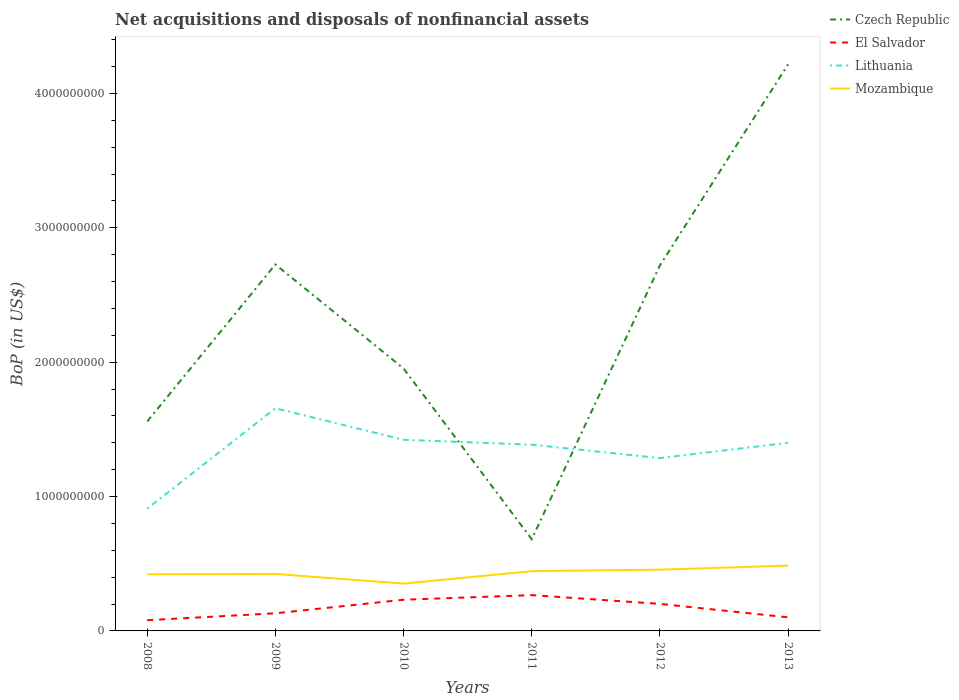Does the line corresponding to Lithuania intersect with the line corresponding to Mozambique?
Your response must be concise. No. Is the number of lines equal to the number of legend labels?
Ensure brevity in your answer.  Yes. Across all years, what is the maximum Balance of Payments in Mozambique?
Provide a short and direct response. 3.52e+08. In which year was the Balance of Payments in Mozambique maximum?
Your response must be concise. 2010. What is the total Balance of Payments in Mozambique in the graph?
Offer a terse response. 6.94e+07. What is the difference between the highest and the second highest Balance of Payments in Mozambique?
Provide a short and direct response. 1.34e+08. How many lines are there?
Offer a terse response. 4. How many years are there in the graph?
Offer a very short reply. 6. Are the values on the major ticks of Y-axis written in scientific E-notation?
Your answer should be compact. No. How many legend labels are there?
Your answer should be compact. 4. How are the legend labels stacked?
Ensure brevity in your answer.  Vertical. What is the title of the graph?
Ensure brevity in your answer.  Net acquisitions and disposals of nonfinancial assets. What is the label or title of the X-axis?
Provide a succinct answer. Years. What is the label or title of the Y-axis?
Offer a terse response. BoP (in US$). What is the BoP (in US$) in Czech Republic in 2008?
Offer a very short reply. 1.56e+09. What is the BoP (in US$) in El Salvador in 2008?
Your response must be concise. 7.98e+07. What is the BoP (in US$) in Lithuania in 2008?
Your response must be concise. 9.10e+08. What is the BoP (in US$) of Mozambique in 2008?
Offer a very short reply. 4.21e+08. What is the BoP (in US$) of Czech Republic in 2009?
Your answer should be compact. 2.73e+09. What is the BoP (in US$) of El Salvador in 2009?
Keep it short and to the point. 1.31e+08. What is the BoP (in US$) in Lithuania in 2009?
Keep it short and to the point. 1.66e+09. What is the BoP (in US$) of Mozambique in 2009?
Your response must be concise. 4.24e+08. What is the BoP (in US$) in Czech Republic in 2010?
Ensure brevity in your answer.  1.95e+09. What is the BoP (in US$) of El Salvador in 2010?
Make the answer very short. 2.32e+08. What is the BoP (in US$) in Lithuania in 2010?
Your answer should be compact. 1.42e+09. What is the BoP (in US$) of Mozambique in 2010?
Ensure brevity in your answer.  3.52e+08. What is the BoP (in US$) of Czech Republic in 2011?
Give a very brief answer. 6.83e+08. What is the BoP (in US$) of El Salvador in 2011?
Provide a succinct answer. 2.66e+08. What is the BoP (in US$) in Lithuania in 2011?
Your response must be concise. 1.39e+09. What is the BoP (in US$) of Mozambique in 2011?
Offer a terse response. 4.45e+08. What is the BoP (in US$) in Czech Republic in 2012?
Provide a short and direct response. 2.72e+09. What is the BoP (in US$) of El Salvador in 2012?
Offer a terse response. 2.01e+08. What is the BoP (in US$) of Lithuania in 2012?
Your answer should be compact. 1.29e+09. What is the BoP (in US$) in Mozambique in 2012?
Give a very brief answer. 4.56e+08. What is the BoP (in US$) in Czech Republic in 2013?
Your answer should be compact. 4.22e+09. What is the BoP (in US$) of El Salvador in 2013?
Your response must be concise. 1.01e+08. What is the BoP (in US$) of Lithuania in 2013?
Ensure brevity in your answer.  1.40e+09. What is the BoP (in US$) of Mozambique in 2013?
Keep it short and to the point. 4.86e+08. Across all years, what is the maximum BoP (in US$) of Czech Republic?
Keep it short and to the point. 4.22e+09. Across all years, what is the maximum BoP (in US$) in El Salvador?
Offer a very short reply. 2.66e+08. Across all years, what is the maximum BoP (in US$) in Lithuania?
Provide a succinct answer. 1.66e+09. Across all years, what is the maximum BoP (in US$) in Mozambique?
Your answer should be compact. 4.86e+08. Across all years, what is the minimum BoP (in US$) of Czech Republic?
Give a very brief answer. 6.83e+08. Across all years, what is the minimum BoP (in US$) of El Salvador?
Your response must be concise. 7.98e+07. Across all years, what is the minimum BoP (in US$) in Lithuania?
Offer a very short reply. 9.10e+08. Across all years, what is the minimum BoP (in US$) in Mozambique?
Give a very brief answer. 3.52e+08. What is the total BoP (in US$) of Czech Republic in the graph?
Give a very brief answer. 1.39e+1. What is the total BoP (in US$) in El Salvador in the graph?
Offer a terse response. 1.01e+09. What is the total BoP (in US$) in Lithuania in the graph?
Provide a short and direct response. 8.06e+09. What is the total BoP (in US$) of Mozambique in the graph?
Your answer should be compact. 2.58e+09. What is the difference between the BoP (in US$) in Czech Republic in 2008 and that in 2009?
Give a very brief answer. -1.17e+09. What is the difference between the BoP (in US$) of El Salvador in 2008 and that in 2009?
Your answer should be compact. -5.14e+07. What is the difference between the BoP (in US$) of Lithuania in 2008 and that in 2009?
Offer a very short reply. -7.47e+08. What is the difference between the BoP (in US$) in Mozambique in 2008 and that in 2009?
Provide a succinct answer. -2.73e+06. What is the difference between the BoP (in US$) in Czech Republic in 2008 and that in 2010?
Provide a succinct answer. -3.94e+08. What is the difference between the BoP (in US$) of El Salvador in 2008 and that in 2010?
Provide a succinct answer. -1.52e+08. What is the difference between the BoP (in US$) of Lithuania in 2008 and that in 2010?
Provide a short and direct response. -5.12e+08. What is the difference between the BoP (in US$) in Mozambique in 2008 and that in 2010?
Give a very brief answer. 6.94e+07. What is the difference between the BoP (in US$) of Czech Republic in 2008 and that in 2011?
Provide a short and direct response. 8.76e+08. What is the difference between the BoP (in US$) of El Salvador in 2008 and that in 2011?
Offer a terse response. -1.87e+08. What is the difference between the BoP (in US$) of Lithuania in 2008 and that in 2011?
Give a very brief answer. -4.76e+08. What is the difference between the BoP (in US$) of Mozambique in 2008 and that in 2011?
Your response must be concise. -2.33e+07. What is the difference between the BoP (in US$) of Czech Republic in 2008 and that in 2012?
Ensure brevity in your answer.  -1.16e+09. What is the difference between the BoP (in US$) in El Salvador in 2008 and that in 2012?
Make the answer very short. -1.21e+08. What is the difference between the BoP (in US$) of Lithuania in 2008 and that in 2012?
Give a very brief answer. -3.76e+08. What is the difference between the BoP (in US$) of Mozambique in 2008 and that in 2012?
Offer a terse response. -3.45e+07. What is the difference between the BoP (in US$) in Czech Republic in 2008 and that in 2013?
Keep it short and to the point. -2.66e+09. What is the difference between the BoP (in US$) of El Salvador in 2008 and that in 2013?
Make the answer very short. -2.13e+07. What is the difference between the BoP (in US$) of Lithuania in 2008 and that in 2013?
Keep it short and to the point. -4.90e+08. What is the difference between the BoP (in US$) in Mozambique in 2008 and that in 2013?
Your response must be concise. -6.43e+07. What is the difference between the BoP (in US$) of Czech Republic in 2009 and that in 2010?
Make the answer very short. 7.74e+08. What is the difference between the BoP (in US$) in El Salvador in 2009 and that in 2010?
Make the answer very short. -1.01e+08. What is the difference between the BoP (in US$) of Lithuania in 2009 and that in 2010?
Your answer should be compact. 2.35e+08. What is the difference between the BoP (in US$) in Mozambique in 2009 and that in 2010?
Offer a terse response. 7.21e+07. What is the difference between the BoP (in US$) of Czech Republic in 2009 and that in 2011?
Provide a succinct answer. 2.04e+09. What is the difference between the BoP (in US$) of El Salvador in 2009 and that in 2011?
Offer a very short reply. -1.35e+08. What is the difference between the BoP (in US$) of Lithuania in 2009 and that in 2011?
Offer a very short reply. 2.71e+08. What is the difference between the BoP (in US$) in Mozambique in 2009 and that in 2011?
Make the answer very short. -2.06e+07. What is the difference between the BoP (in US$) of Czech Republic in 2009 and that in 2012?
Provide a short and direct response. 7.45e+06. What is the difference between the BoP (in US$) in El Salvador in 2009 and that in 2012?
Offer a very short reply. -7.00e+07. What is the difference between the BoP (in US$) of Lithuania in 2009 and that in 2012?
Offer a terse response. 3.71e+08. What is the difference between the BoP (in US$) in Mozambique in 2009 and that in 2012?
Offer a very short reply. -3.18e+07. What is the difference between the BoP (in US$) in Czech Republic in 2009 and that in 2013?
Your answer should be compact. -1.49e+09. What is the difference between the BoP (in US$) in El Salvador in 2009 and that in 2013?
Offer a terse response. 3.01e+07. What is the difference between the BoP (in US$) of Lithuania in 2009 and that in 2013?
Ensure brevity in your answer.  2.57e+08. What is the difference between the BoP (in US$) in Mozambique in 2009 and that in 2013?
Provide a short and direct response. -6.15e+07. What is the difference between the BoP (in US$) of Czech Republic in 2010 and that in 2011?
Offer a very short reply. 1.27e+09. What is the difference between the BoP (in US$) of El Salvador in 2010 and that in 2011?
Provide a short and direct response. -3.44e+07. What is the difference between the BoP (in US$) in Lithuania in 2010 and that in 2011?
Keep it short and to the point. 3.64e+07. What is the difference between the BoP (in US$) of Mozambique in 2010 and that in 2011?
Your answer should be compact. -9.28e+07. What is the difference between the BoP (in US$) in Czech Republic in 2010 and that in 2012?
Ensure brevity in your answer.  -7.66e+08. What is the difference between the BoP (in US$) of El Salvador in 2010 and that in 2012?
Ensure brevity in your answer.  3.08e+07. What is the difference between the BoP (in US$) of Lithuania in 2010 and that in 2012?
Ensure brevity in your answer.  1.36e+08. What is the difference between the BoP (in US$) in Mozambique in 2010 and that in 2012?
Your answer should be compact. -1.04e+08. What is the difference between the BoP (in US$) of Czech Republic in 2010 and that in 2013?
Offer a terse response. -2.26e+09. What is the difference between the BoP (in US$) of El Salvador in 2010 and that in 2013?
Provide a short and direct response. 1.31e+08. What is the difference between the BoP (in US$) of Lithuania in 2010 and that in 2013?
Make the answer very short. 2.24e+07. What is the difference between the BoP (in US$) in Mozambique in 2010 and that in 2013?
Provide a short and direct response. -1.34e+08. What is the difference between the BoP (in US$) in Czech Republic in 2011 and that in 2012?
Make the answer very short. -2.04e+09. What is the difference between the BoP (in US$) in El Salvador in 2011 and that in 2012?
Keep it short and to the point. 6.52e+07. What is the difference between the BoP (in US$) in Lithuania in 2011 and that in 2012?
Provide a short and direct response. 9.96e+07. What is the difference between the BoP (in US$) of Mozambique in 2011 and that in 2012?
Offer a very short reply. -1.11e+07. What is the difference between the BoP (in US$) in Czech Republic in 2011 and that in 2013?
Give a very brief answer. -3.53e+09. What is the difference between the BoP (in US$) of El Salvador in 2011 and that in 2013?
Your answer should be compact. 1.65e+08. What is the difference between the BoP (in US$) of Lithuania in 2011 and that in 2013?
Provide a short and direct response. -1.40e+07. What is the difference between the BoP (in US$) in Mozambique in 2011 and that in 2013?
Ensure brevity in your answer.  -4.09e+07. What is the difference between the BoP (in US$) of Czech Republic in 2012 and that in 2013?
Provide a succinct answer. -1.50e+09. What is the difference between the BoP (in US$) in El Salvador in 2012 and that in 2013?
Your answer should be very brief. 1.00e+08. What is the difference between the BoP (in US$) of Lithuania in 2012 and that in 2013?
Your answer should be very brief. -1.14e+08. What is the difference between the BoP (in US$) in Mozambique in 2012 and that in 2013?
Keep it short and to the point. -2.98e+07. What is the difference between the BoP (in US$) in Czech Republic in 2008 and the BoP (in US$) in El Salvador in 2009?
Ensure brevity in your answer.  1.43e+09. What is the difference between the BoP (in US$) of Czech Republic in 2008 and the BoP (in US$) of Lithuania in 2009?
Your response must be concise. -9.84e+07. What is the difference between the BoP (in US$) in Czech Republic in 2008 and the BoP (in US$) in Mozambique in 2009?
Your response must be concise. 1.13e+09. What is the difference between the BoP (in US$) in El Salvador in 2008 and the BoP (in US$) in Lithuania in 2009?
Offer a terse response. -1.58e+09. What is the difference between the BoP (in US$) in El Salvador in 2008 and the BoP (in US$) in Mozambique in 2009?
Ensure brevity in your answer.  -3.44e+08. What is the difference between the BoP (in US$) of Lithuania in 2008 and the BoP (in US$) of Mozambique in 2009?
Provide a short and direct response. 4.86e+08. What is the difference between the BoP (in US$) in Czech Republic in 2008 and the BoP (in US$) in El Salvador in 2010?
Make the answer very short. 1.33e+09. What is the difference between the BoP (in US$) of Czech Republic in 2008 and the BoP (in US$) of Lithuania in 2010?
Keep it short and to the point. 1.36e+08. What is the difference between the BoP (in US$) of Czech Republic in 2008 and the BoP (in US$) of Mozambique in 2010?
Provide a short and direct response. 1.21e+09. What is the difference between the BoP (in US$) of El Salvador in 2008 and the BoP (in US$) of Lithuania in 2010?
Offer a very short reply. -1.34e+09. What is the difference between the BoP (in US$) in El Salvador in 2008 and the BoP (in US$) in Mozambique in 2010?
Your answer should be compact. -2.72e+08. What is the difference between the BoP (in US$) of Lithuania in 2008 and the BoP (in US$) of Mozambique in 2010?
Your answer should be compact. 5.58e+08. What is the difference between the BoP (in US$) in Czech Republic in 2008 and the BoP (in US$) in El Salvador in 2011?
Ensure brevity in your answer.  1.29e+09. What is the difference between the BoP (in US$) in Czech Republic in 2008 and the BoP (in US$) in Lithuania in 2011?
Keep it short and to the point. 1.73e+08. What is the difference between the BoP (in US$) of Czech Republic in 2008 and the BoP (in US$) of Mozambique in 2011?
Provide a succinct answer. 1.11e+09. What is the difference between the BoP (in US$) of El Salvador in 2008 and the BoP (in US$) of Lithuania in 2011?
Provide a succinct answer. -1.31e+09. What is the difference between the BoP (in US$) in El Salvador in 2008 and the BoP (in US$) in Mozambique in 2011?
Offer a very short reply. -3.65e+08. What is the difference between the BoP (in US$) of Lithuania in 2008 and the BoP (in US$) of Mozambique in 2011?
Your answer should be very brief. 4.65e+08. What is the difference between the BoP (in US$) of Czech Republic in 2008 and the BoP (in US$) of El Salvador in 2012?
Offer a very short reply. 1.36e+09. What is the difference between the BoP (in US$) in Czech Republic in 2008 and the BoP (in US$) in Lithuania in 2012?
Your answer should be very brief. 2.72e+08. What is the difference between the BoP (in US$) in Czech Republic in 2008 and the BoP (in US$) in Mozambique in 2012?
Provide a short and direct response. 1.10e+09. What is the difference between the BoP (in US$) in El Salvador in 2008 and the BoP (in US$) in Lithuania in 2012?
Provide a succinct answer. -1.21e+09. What is the difference between the BoP (in US$) in El Salvador in 2008 and the BoP (in US$) in Mozambique in 2012?
Offer a terse response. -3.76e+08. What is the difference between the BoP (in US$) in Lithuania in 2008 and the BoP (in US$) in Mozambique in 2012?
Provide a succinct answer. 4.54e+08. What is the difference between the BoP (in US$) of Czech Republic in 2008 and the BoP (in US$) of El Salvador in 2013?
Offer a very short reply. 1.46e+09. What is the difference between the BoP (in US$) of Czech Republic in 2008 and the BoP (in US$) of Lithuania in 2013?
Offer a very short reply. 1.59e+08. What is the difference between the BoP (in US$) of Czech Republic in 2008 and the BoP (in US$) of Mozambique in 2013?
Your response must be concise. 1.07e+09. What is the difference between the BoP (in US$) in El Salvador in 2008 and the BoP (in US$) in Lithuania in 2013?
Your answer should be compact. -1.32e+09. What is the difference between the BoP (in US$) of El Salvador in 2008 and the BoP (in US$) of Mozambique in 2013?
Your answer should be very brief. -4.06e+08. What is the difference between the BoP (in US$) in Lithuania in 2008 and the BoP (in US$) in Mozambique in 2013?
Your answer should be compact. 4.24e+08. What is the difference between the BoP (in US$) in Czech Republic in 2009 and the BoP (in US$) in El Salvador in 2010?
Give a very brief answer. 2.49e+09. What is the difference between the BoP (in US$) in Czech Republic in 2009 and the BoP (in US$) in Lithuania in 2010?
Your response must be concise. 1.30e+09. What is the difference between the BoP (in US$) of Czech Republic in 2009 and the BoP (in US$) of Mozambique in 2010?
Offer a terse response. 2.37e+09. What is the difference between the BoP (in US$) of El Salvador in 2009 and the BoP (in US$) of Lithuania in 2010?
Offer a very short reply. -1.29e+09. What is the difference between the BoP (in US$) in El Salvador in 2009 and the BoP (in US$) in Mozambique in 2010?
Your response must be concise. -2.21e+08. What is the difference between the BoP (in US$) in Lithuania in 2009 and the BoP (in US$) in Mozambique in 2010?
Offer a very short reply. 1.30e+09. What is the difference between the BoP (in US$) in Czech Republic in 2009 and the BoP (in US$) in El Salvador in 2011?
Provide a short and direct response. 2.46e+09. What is the difference between the BoP (in US$) in Czech Republic in 2009 and the BoP (in US$) in Lithuania in 2011?
Offer a terse response. 1.34e+09. What is the difference between the BoP (in US$) of Czech Republic in 2009 and the BoP (in US$) of Mozambique in 2011?
Your response must be concise. 2.28e+09. What is the difference between the BoP (in US$) of El Salvador in 2009 and the BoP (in US$) of Lithuania in 2011?
Provide a succinct answer. -1.25e+09. What is the difference between the BoP (in US$) in El Salvador in 2009 and the BoP (in US$) in Mozambique in 2011?
Offer a terse response. -3.14e+08. What is the difference between the BoP (in US$) in Lithuania in 2009 and the BoP (in US$) in Mozambique in 2011?
Provide a short and direct response. 1.21e+09. What is the difference between the BoP (in US$) in Czech Republic in 2009 and the BoP (in US$) in El Salvador in 2012?
Provide a succinct answer. 2.53e+09. What is the difference between the BoP (in US$) of Czech Republic in 2009 and the BoP (in US$) of Lithuania in 2012?
Your response must be concise. 1.44e+09. What is the difference between the BoP (in US$) in Czech Republic in 2009 and the BoP (in US$) in Mozambique in 2012?
Give a very brief answer. 2.27e+09. What is the difference between the BoP (in US$) of El Salvador in 2009 and the BoP (in US$) of Lithuania in 2012?
Offer a very short reply. -1.15e+09. What is the difference between the BoP (in US$) in El Salvador in 2009 and the BoP (in US$) in Mozambique in 2012?
Your answer should be very brief. -3.25e+08. What is the difference between the BoP (in US$) in Lithuania in 2009 and the BoP (in US$) in Mozambique in 2012?
Your answer should be compact. 1.20e+09. What is the difference between the BoP (in US$) in Czech Republic in 2009 and the BoP (in US$) in El Salvador in 2013?
Make the answer very short. 2.63e+09. What is the difference between the BoP (in US$) in Czech Republic in 2009 and the BoP (in US$) in Lithuania in 2013?
Offer a very short reply. 1.33e+09. What is the difference between the BoP (in US$) in Czech Republic in 2009 and the BoP (in US$) in Mozambique in 2013?
Your response must be concise. 2.24e+09. What is the difference between the BoP (in US$) of El Salvador in 2009 and the BoP (in US$) of Lithuania in 2013?
Make the answer very short. -1.27e+09. What is the difference between the BoP (in US$) of El Salvador in 2009 and the BoP (in US$) of Mozambique in 2013?
Provide a succinct answer. -3.55e+08. What is the difference between the BoP (in US$) in Lithuania in 2009 and the BoP (in US$) in Mozambique in 2013?
Provide a succinct answer. 1.17e+09. What is the difference between the BoP (in US$) of Czech Republic in 2010 and the BoP (in US$) of El Salvador in 2011?
Keep it short and to the point. 1.69e+09. What is the difference between the BoP (in US$) in Czech Republic in 2010 and the BoP (in US$) in Lithuania in 2011?
Your response must be concise. 5.67e+08. What is the difference between the BoP (in US$) in Czech Republic in 2010 and the BoP (in US$) in Mozambique in 2011?
Offer a very short reply. 1.51e+09. What is the difference between the BoP (in US$) of El Salvador in 2010 and the BoP (in US$) of Lithuania in 2011?
Provide a succinct answer. -1.15e+09. What is the difference between the BoP (in US$) of El Salvador in 2010 and the BoP (in US$) of Mozambique in 2011?
Give a very brief answer. -2.13e+08. What is the difference between the BoP (in US$) of Lithuania in 2010 and the BoP (in US$) of Mozambique in 2011?
Offer a terse response. 9.77e+08. What is the difference between the BoP (in US$) in Czech Republic in 2010 and the BoP (in US$) in El Salvador in 2012?
Provide a succinct answer. 1.75e+09. What is the difference between the BoP (in US$) in Czech Republic in 2010 and the BoP (in US$) in Lithuania in 2012?
Your answer should be very brief. 6.67e+08. What is the difference between the BoP (in US$) in Czech Republic in 2010 and the BoP (in US$) in Mozambique in 2012?
Make the answer very short. 1.50e+09. What is the difference between the BoP (in US$) of El Salvador in 2010 and the BoP (in US$) of Lithuania in 2012?
Your response must be concise. -1.05e+09. What is the difference between the BoP (in US$) in El Salvador in 2010 and the BoP (in US$) in Mozambique in 2012?
Your response must be concise. -2.24e+08. What is the difference between the BoP (in US$) of Lithuania in 2010 and the BoP (in US$) of Mozambique in 2012?
Provide a succinct answer. 9.66e+08. What is the difference between the BoP (in US$) of Czech Republic in 2010 and the BoP (in US$) of El Salvador in 2013?
Provide a succinct answer. 1.85e+09. What is the difference between the BoP (in US$) in Czech Republic in 2010 and the BoP (in US$) in Lithuania in 2013?
Provide a succinct answer. 5.53e+08. What is the difference between the BoP (in US$) of Czech Republic in 2010 and the BoP (in US$) of Mozambique in 2013?
Ensure brevity in your answer.  1.47e+09. What is the difference between the BoP (in US$) of El Salvador in 2010 and the BoP (in US$) of Lithuania in 2013?
Offer a very short reply. -1.17e+09. What is the difference between the BoP (in US$) in El Salvador in 2010 and the BoP (in US$) in Mozambique in 2013?
Provide a succinct answer. -2.54e+08. What is the difference between the BoP (in US$) in Lithuania in 2010 and the BoP (in US$) in Mozambique in 2013?
Provide a short and direct response. 9.36e+08. What is the difference between the BoP (in US$) in Czech Republic in 2011 and the BoP (in US$) in El Salvador in 2012?
Offer a terse response. 4.81e+08. What is the difference between the BoP (in US$) in Czech Republic in 2011 and the BoP (in US$) in Lithuania in 2012?
Make the answer very short. -6.04e+08. What is the difference between the BoP (in US$) in Czech Republic in 2011 and the BoP (in US$) in Mozambique in 2012?
Ensure brevity in your answer.  2.27e+08. What is the difference between the BoP (in US$) in El Salvador in 2011 and the BoP (in US$) in Lithuania in 2012?
Your response must be concise. -1.02e+09. What is the difference between the BoP (in US$) in El Salvador in 2011 and the BoP (in US$) in Mozambique in 2012?
Ensure brevity in your answer.  -1.90e+08. What is the difference between the BoP (in US$) of Lithuania in 2011 and the BoP (in US$) of Mozambique in 2012?
Your answer should be very brief. 9.30e+08. What is the difference between the BoP (in US$) of Czech Republic in 2011 and the BoP (in US$) of El Salvador in 2013?
Offer a terse response. 5.81e+08. What is the difference between the BoP (in US$) in Czech Republic in 2011 and the BoP (in US$) in Lithuania in 2013?
Offer a very short reply. -7.17e+08. What is the difference between the BoP (in US$) in Czech Republic in 2011 and the BoP (in US$) in Mozambique in 2013?
Give a very brief answer. 1.97e+08. What is the difference between the BoP (in US$) in El Salvador in 2011 and the BoP (in US$) in Lithuania in 2013?
Give a very brief answer. -1.13e+09. What is the difference between the BoP (in US$) in El Salvador in 2011 and the BoP (in US$) in Mozambique in 2013?
Make the answer very short. -2.19e+08. What is the difference between the BoP (in US$) in Lithuania in 2011 and the BoP (in US$) in Mozambique in 2013?
Give a very brief answer. 9.00e+08. What is the difference between the BoP (in US$) of Czech Republic in 2012 and the BoP (in US$) of El Salvador in 2013?
Offer a very short reply. 2.62e+09. What is the difference between the BoP (in US$) of Czech Republic in 2012 and the BoP (in US$) of Lithuania in 2013?
Keep it short and to the point. 1.32e+09. What is the difference between the BoP (in US$) in Czech Republic in 2012 and the BoP (in US$) in Mozambique in 2013?
Offer a very short reply. 2.23e+09. What is the difference between the BoP (in US$) of El Salvador in 2012 and the BoP (in US$) of Lithuania in 2013?
Keep it short and to the point. -1.20e+09. What is the difference between the BoP (in US$) in El Salvador in 2012 and the BoP (in US$) in Mozambique in 2013?
Provide a succinct answer. -2.85e+08. What is the difference between the BoP (in US$) of Lithuania in 2012 and the BoP (in US$) of Mozambique in 2013?
Make the answer very short. 8.00e+08. What is the average BoP (in US$) of Czech Republic per year?
Offer a terse response. 2.31e+09. What is the average BoP (in US$) of El Salvador per year?
Give a very brief answer. 1.69e+08. What is the average BoP (in US$) in Lithuania per year?
Offer a terse response. 1.34e+09. What is the average BoP (in US$) of Mozambique per year?
Make the answer very short. 4.31e+08. In the year 2008, what is the difference between the BoP (in US$) in Czech Republic and BoP (in US$) in El Salvador?
Your answer should be compact. 1.48e+09. In the year 2008, what is the difference between the BoP (in US$) in Czech Republic and BoP (in US$) in Lithuania?
Your response must be concise. 6.49e+08. In the year 2008, what is the difference between the BoP (in US$) in Czech Republic and BoP (in US$) in Mozambique?
Your answer should be very brief. 1.14e+09. In the year 2008, what is the difference between the BoP (in US$) in El Salvador and BoP (in US$) in Lithuania?
Ensure brevity in your answer.  -8.30e+08. In the year 2008, what is the difference between the BoP (in US$) in El Salvador and BoP (in US$) in Mozambique?
Provide a short and direct response. -3.42e+08. In the year 2008, what is the difference between the BoP (in US$) of Lithuania and BoP (in US$) of Mozambique?
Offer a very short reply. 4.89e+08. In the year 2009, what is the difference between the BoP (in US$) of Czech Republic and BoP (in US$) of El Salvador?
Your response must be concise. 2.60e+09. In the year 2009, what is the difference between the BoP (in US$) in Czech Republic and BoP (in US$) in Lithuania?
Offer a terse response. 1.07e+09. In the year 2009, what is the difference between the BoP (in US$) of Czech Republic and BoP (in US$) of Mozambique?
Your answer should be very brief. 2.30e+09. In the year 2009, what is the difference between the BoP (in US$) of El Salvador and BoP (in US$) of Lithuania?
Offer a very short reply. -1.53e+09. In the year 2009, what is the difference between the BoP (in US$) in El Salvador and BoP (in US$) in Mozambique?
Make the answer very short. -2.93e+08. In the year 2009, what is the difference between the BoP (in US$) in Lithuania and BoP (in US$) in Mozambique?
Provide a short and direct response. 1.23e+09. In the year 2010, what is the difference between the BoP (in US$) of Czech Republic and BoP (in US$) of El Salvador?
Your answer should be compact. 1.72e+09. In the year 2010, what is the difference between the BoP (in US$) of Czech Republic and BoP (in US$) of Lithuania?
Provide a succinct answer. 5.31e+08. In the year 2010, what is the difference between the BoP (in US$) of Czech Republic and BoP (in US$) of Mozambique?
Ensure brevity in your answer.  1.60e+09. In the year 2010, what is the difference between the BoP (in US$) of El Salvador and BoP (in US$) of Lithuania?
Your answer should be very brief. -1.19e+09. In the year 2010, what is the difference between the BoP (in US$) of El Salvador and BoP (in US$) of Mozambique?
Give a very brief answer. -1.20e+08. In the year 2010, what is the difference between the BoP (in US$) in Lithuania and BoP (in US$) in Mozambique?
Your answer should be compact. 1.07e+09. In the year 2011, what is the difference between the BoP (in US$) of Czech Republic and BoP (in US$) of El Salvador?
Your answer should be very brief. 4.16e+08. In the year 2011, what is the difference between the BoP (in US$) of Czech Republic and BoP (in US$) of Lithuania?
Your answer should be very brief. -7.03e+08. In the year 2011, what is the difference between the BoP (in US$) in Czech Republic and BoP (in US$) in Mozambique?
Give a very brief answer. 2.38e+08. In the year 2011, what is the difference between the BoP (in US$) of El Salvador and BoP (in US$) of Lithuania?
Ensure brevity in your answer.  -1.12e+09. In the year 2011, what is the difference between the BoP (in US$) of El Salvador and BoP (in US$) of Mozambique?
Provide a short and direct response. -1.78e+08. In the year 2011, what is the difference between the BoP (in US$) in Lithuania and BoP (in US$) in Mozambique?
Your response must be concise. 9.41e+08. In the year 2012, what is the difference between the BoP (in US$) in Czech Republic and BoP (in US$) in El Salvador?
Your answer should be compact. 2.52e+09. In the year 2012, what is the difference between the BoP (in US$) in Czech Republic and BoP (in US$) in Lithuania?
Your response must be concise. 1.43e+09. In the year 2012, what is the difference between the BoP (in US$) of Czech Republic and BoP (in US$) of Mozambique?
Keep it short and to the point. 2.26e+09. In the year 2012, what is the difference between the BoP (in US$) of El Salvador and BoP (in US$) of Lithuania?
Provide a short and direct response. -1.08e+09. In the year 2012, what is the difference between the BoP (in US$) of El Salvador and BoP (in US$) of Mozambique?
Offer a terse response. -2.55e+08. In the year 2012, what is the difference between the BoP (in US$) of Lithuania and BoP (in US$) of Mozambique?
Keep it short and to the point. 8.30e+08. In the year 2013, what is the difference between the BoP (in US$) in Czech Republic and BoP (in US$) in El Salvador?
Make the answer very short. 4.11e+09. In the year 2013, what is the difference between the BoP (in US$) of Czech Republic and BoP (in US$) of Lithuania?
Make the answer very short. 2.82e+09. In the year 2013, what is the difference between the BoP (in US$) in Czech Republic and BoP (in US$) in Mozambique?
Your response must be concise. 3.73e+09. In the year 2013, what is the difference between the BoP (in US$) in El Salvador and BoP (in US$) in Lithuania?
Offer a very short reply. -1.30e+09. In the year 2013, what is the difference between the BoP (in US$) in El Salvador and BoP (in US$) in Mozambique?
Provide a succinct answer. -3.85e+08. In the year 2013, what is the difference between the BoP (in US$) of Lithuania and BoP (in US$) of Mozambique?
Give a very brief answer. 9.14e+08. What is the ratio of the BoP (in US$) in Czech Republic in 2008 to that in 2009?
Offer a very short reply. 0.57. What is the ratio of the BoP (in US$) in El Salvador in 2008 to that in 2009?
Provide a short and direct response. 0.61. What is the ratio of the BoP (in US$) of Lithuania in 2008 to that in 2009?
Give a very brief answer. 0.55. What is the ratio of the BoP (in US$) in Czech Republic in 2008 to that in 2010?
Keep it short and to the point. 0.8. What is the ratio of the BoP (in US$) of El Salvador in 2008 to that in 2010?
Offer a very short reply. 0.34. What is the ratio of the BoP (in US$) in Lithuania in 2008 to that in 2010?
Keep it short and to the point. 0.64. What is the ratio of the BoP (in US$) in Mozambique in 2008 to that in 2010?
Offer a terse response. 1.2. What is the ratio of the BoP (in US$) of Czech Republic in 2008 to that in 2011?
Offer a very short reply. 2.28. What is the ratio of the BoP (in US$) in El Salvador in 2008 to that in 2011?
Provide a short and direct response. 0.3. What is the ratio of the BoP (in US$) in Lithuania in 2008 to that in 2011?
Provide a short and direct response. 0.66. What is the ratio of the BoP (in US$) of Mozambique in 2008 to that in 2011?
Provide a short and direct response. 0.95. What is the ratio of the BoP (in US$) of Czech Republic in 2008 to that in 2012?
Your answer should be very brief. 0.57. What is the ratio of the BoP (in US$) of El Salvador in 2008 to that in 2012?
Your answer should be compact. 0.4. What is the ratio of the BoP (in US$) in Lithuania in 2008 to that in 2012?
Provide a succinct answer. 0.71. What is the ratio of the BoP (in US$) in Mozambique in 2008 to that in 2012?
Your response must be concise. 0.92. What is the ratio of the BoP (in US$) of Czech Republic in 2008 to that in 2013?
Make the answer very short. 0.37. What is the ratio of the BoP (in US$) of El Salvador in 2008 to that in 2013?
Your answer should be compact. 0.79. What is the ratio of the BoP (in US$) in Lithuania in 2008 to that in 2013?
Your answer should be very brief. 0.65. What is the ratio of the BoP (in US$) in Mozambique in 2008 to that in 2013?
Offer a very short reply. 0.87. What is the ratio of the BoP (in US$) of Czech Republic in 2009 to that in 2010?
Provide a short and direct response. 1.4. What is the ratio of the BoP (in US$) of El Salvador in 2009 to that in 2010?
Your answer should be compact. 0.57. What is the ratio of the BoP (in US$) of Lithuania in 2009 to that in 2010?
Make the answer very short. 1.17. What is the ratio of the BoP (in US$) in Mozambique in 2009 to that in 2010?
Offer a terse response. 1.2. What is the ratio of the BoP (in US$) of Czech Republic in 2009 to that in 2011?
Your answer should be very brief. 4. What is the ratio of the BoP (in US$) in El Salvador in 2009 to that in 2011?
Make the answer very short. 0.49. What is the ratio of the BoP (in US$) of Lithuania in 2009 to that in 2011?
Ensure brevity in your answer.  1.2. What is the ratio of the BoP (in US$) in Mozambique in 2009 to that in 2011?
Your answer should be compact. 0.95. What is the ratio of the BoP (in US$) in Czech Republic in 2009 to that in 2012?
Your answer should be very brief. 1. What is the ratio of the BoP (in US$) in El Salvador in 2009 to that in 2012?
Make the answer very short. 0.65. What is the ratio of the BoP (in US$) of Lithuania in 2009 to that in 2012?
Your answer should be very brief. 1.29. What is the ratio of the BoP (in US$) of Mozambique in 2009 to that in 2012?
Provide a succinct answer. 0.93. What is the ratio of the BoP (in US$) in Czech Republic in 2009 to that in 2013?
Make the answer very short. 0.65. What is the ratio of the BoP (in US$) of El Salvador in 2009 to that in 2013?
Give a very brief answer. 1.3. What is the ratio of the BoP (in US$) of Lithuania in 2009 to that in 2013?
Offer a very short reply. 1.18. What is the ratio of the BoP (in US$) in Mozambique in 2009 to that in 2013?
Offer a terse response. 0.87. What is the ratio of the BoP (in US$) in Czech Republic in 2010 to that in 2011?
Offer a very short reply. 2.86. What is the ratio of the BoP (in US$) in El Salvador in 2010 to that in 2011?
Offer a terse response. 0.87. What is the ratio of the BoP (in US$) of Lithuania in 2010 to that in 2011?
Keep it short and to the point. 1.03. What is the ratio of the BoP (in US$) of Mozambique in 2010 to that in 2011?
Provide a succinct answer. 0.79. What is the ratio of the BoP (in US$) of Czech Republic in 2010 to that in 2012?
Make the answer very short. 0.72. What is the ratio of the BoP (in US$) of El Salvador in 2010 to that in 2012?
Offer a terse response. 1.15. What is the ratio of the BoP (in US$) of Lithuania in 2010 to that in 2012?
Provide a short and direct response. 1.11. What is the ratio of the BoP (in US$) of Mozambique in 2010 to that in 2012?
Your answer should be compact. 0.77. What is the ratio of the BoP (in US$) in Czech Republic in 2010 to that in 2013?
Ensure brevity in your answer.  0.46. What is the ratio of the BoP (in US$) of El Salvador in 2010 to that in 2013?
Offer a very short reply. 2.3. What is the ratio of the BoP (in US$) in Lithuania in 2010 to that in 2013?
Offer a very short reply. 1.02. What is the ratio of the BoP (in US$) in Mozambique in 2010 to that in 2013?
Keep it short and to the point. 0.72. What is the ratio of the BoP (in US$) of Czech Republic in 2011 to that in 2012?
Offer a terse response. 0.25. What is the ratio of the BoP (in US$) of El Salvador in 2011 to that in 2012?
Give a very brief answer. 1.32. What is the ratio of the BoP (in US$) in Lithuania in 2011 to that in 2012?
Make the answer very short. 1.08. What is the ratio of the BoP (in US$) in Mozambique in 2011 to that in 2012?
Give a very brief answer. 0.98. What is the ratio of the BoP (in US$) in Czech Republic in 2011 to that in 2013?
Keep it short and to the point. 0.16. What is the ratio of the BoP (in US$) of El Salvador in 2011 to that in 2013?
Offer a terse response. 2.64. What is the ratio of the BoP (in US$) of Mozambique in 2011 to that in 2013?
Offer a terse response. 0.92. What is the ratio of the BoP (in US$) of Czech Republic in 2012 to that in 2013?
Keep it short and to the point. 0.65. What is the ratio of the BoP (in US$) of El Salvador in 2012 to that in 2013?
Give a very brief answer. 1.99. What is the ratio of the BoP (in US$) of Lithuania in 2012 to that in 2013?
Your answer should be very brief. 0.92. What is the ratio of the BoP (in US$) in Mozambique in 2012 to that in 2013?
Offer a terse response. 0.94. What is the difference between the highest and the second highest BoP (in US$) of Czech Republic?
Offer a terse response. 1.49e+09. What is the difference between the highest and the second highest BoP (in US$) of El Salvador?
Give a very brief answer. 3.44e+07. What is the difference between the highest and the second highest BoP (in US$) of Lithuania?
Offer a terse response. 2.35e+08. What is the difference between the highest and the second highest BoP (in US$) of Mozambique?
Keep it short and to the point. 2.98e+07. What is the difference between the highest and the lowest BoP (in US$) in Czech Republic?
Give a very brief answer. 3.53e+09. What is the difference between the highest and the lowest BoP (in US$) of El Salvador?
Offer a very short reply. 1.87e+08. What is the difference between the highest and the lowest BoP (in US$) in Lithuania?
Offer a very short reply. 7.47e+08. What is the difference between the highest and the lowest BoP (in US$) in Mozambique?
Give a very brief answer. 1.34e+08. 